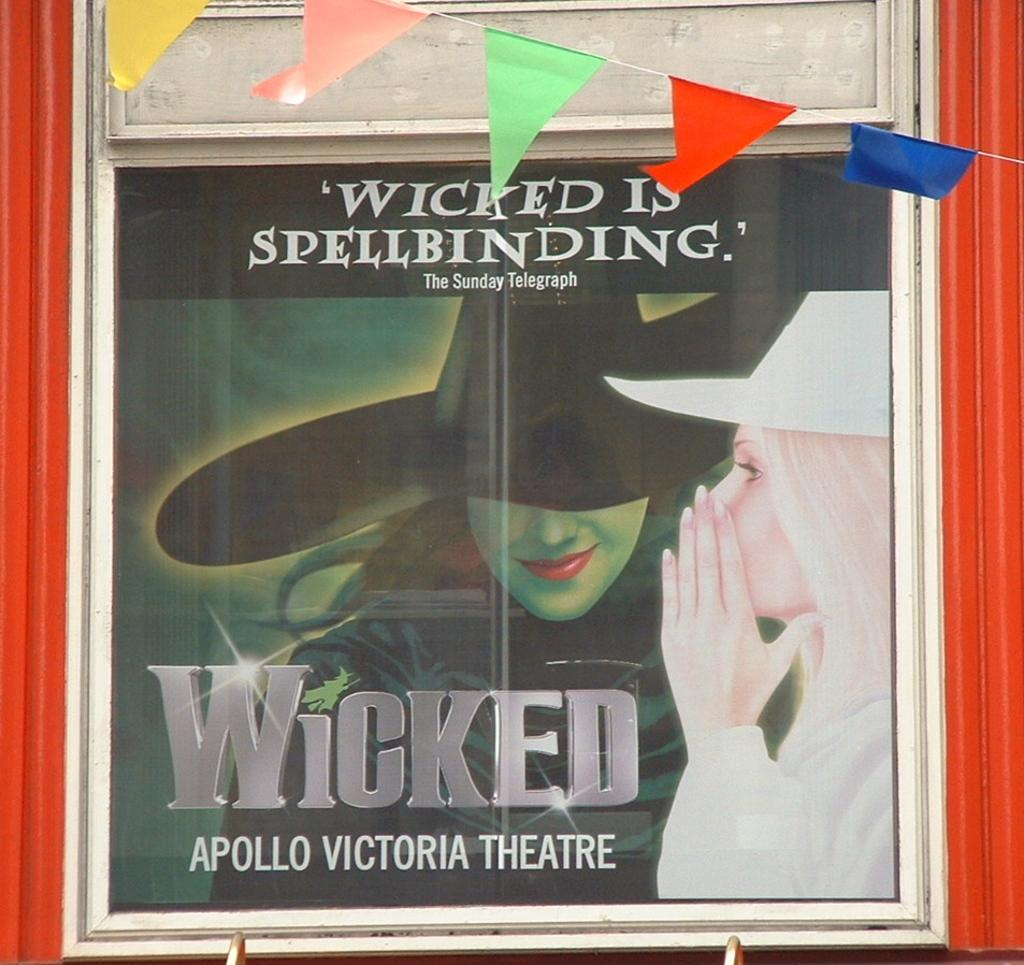<image>
Render a clear and concise summary of the photo. a cd with the word wicked on it 